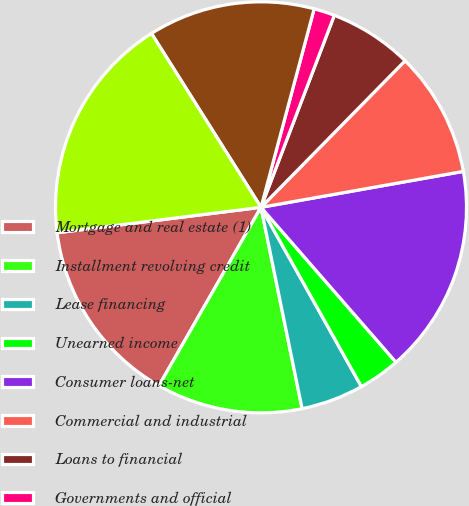<chart> <loc_0><loc_0><loc_500><loc_500><pie_chart><fcel>Mortgage and real estate (1)<fcel>Installment revolving credit<fcel>Lease financing<fcel>Unearned income<fcel>Consumer loans-net<fcel>Commercial and industrial<fcel>Loans to financial<fcel>Governments and official<fcel>Corporate loans-net<fcel>Total loans-net of unearned<nl><fcel>14.75%<fcel>11.48%<fcel>4.92%<fcel>3.28%<fcel>16.39%<fcel>9.84%<fcel>6.56%<fcel>1.64%<fcel>13.11%<fcel>18.03%<nl></chart> 